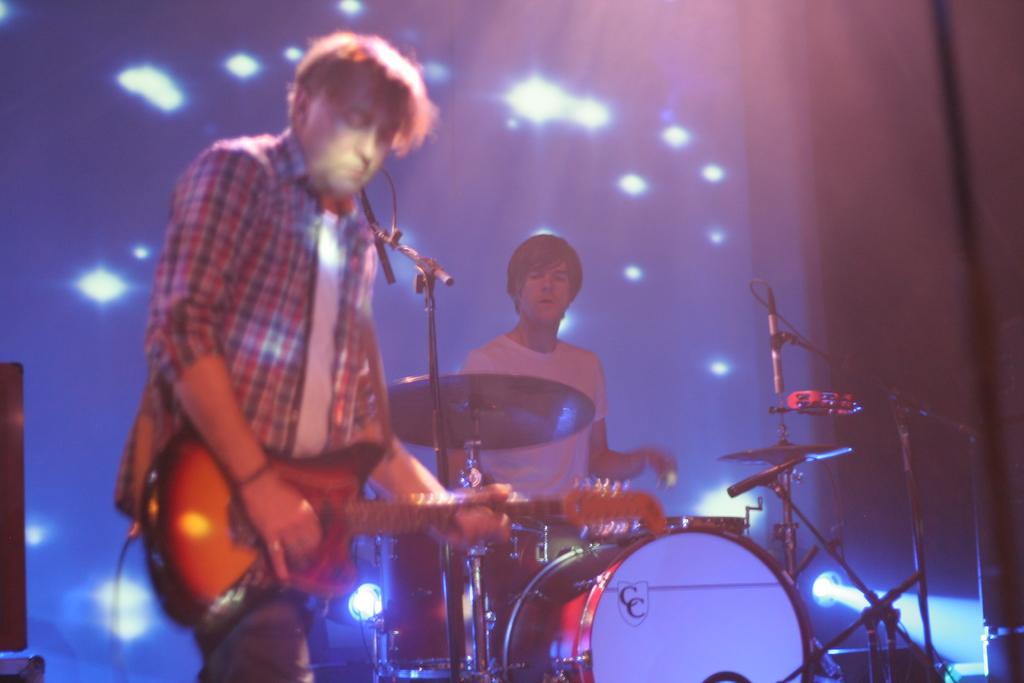Describe this image in one or two sentences. In this image there are two men who are playing the guitar. The man to the right side is beating the drums. At the background there is a curtain and a flash lights on it. 